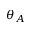Convert formula to latex. <formula><loc_0><loc_0><loc_500><loc_500>\theta _ { A }</formula> 